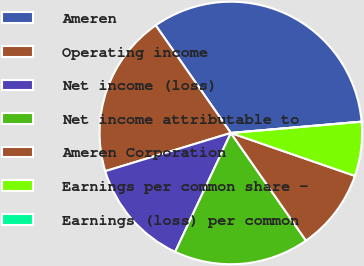Convert chart. <chart><loc_0><loc_0><loc_500><loc_500><pie_chart><fcel>Ameren<fcel>Operating income<fcel>Net income (loss)<fcel>Net income attributable to<fcel>Ameren Corporation<fcel>Earnings per common share -<fcel>Earnings (loss) per common<nl><fcel>33.33%<fcel>20.0%<fcel>13.33%<fcel>16.67%<fcel>10.0%<fcel>6.67%<fcel>0.0%<nl></chart> 